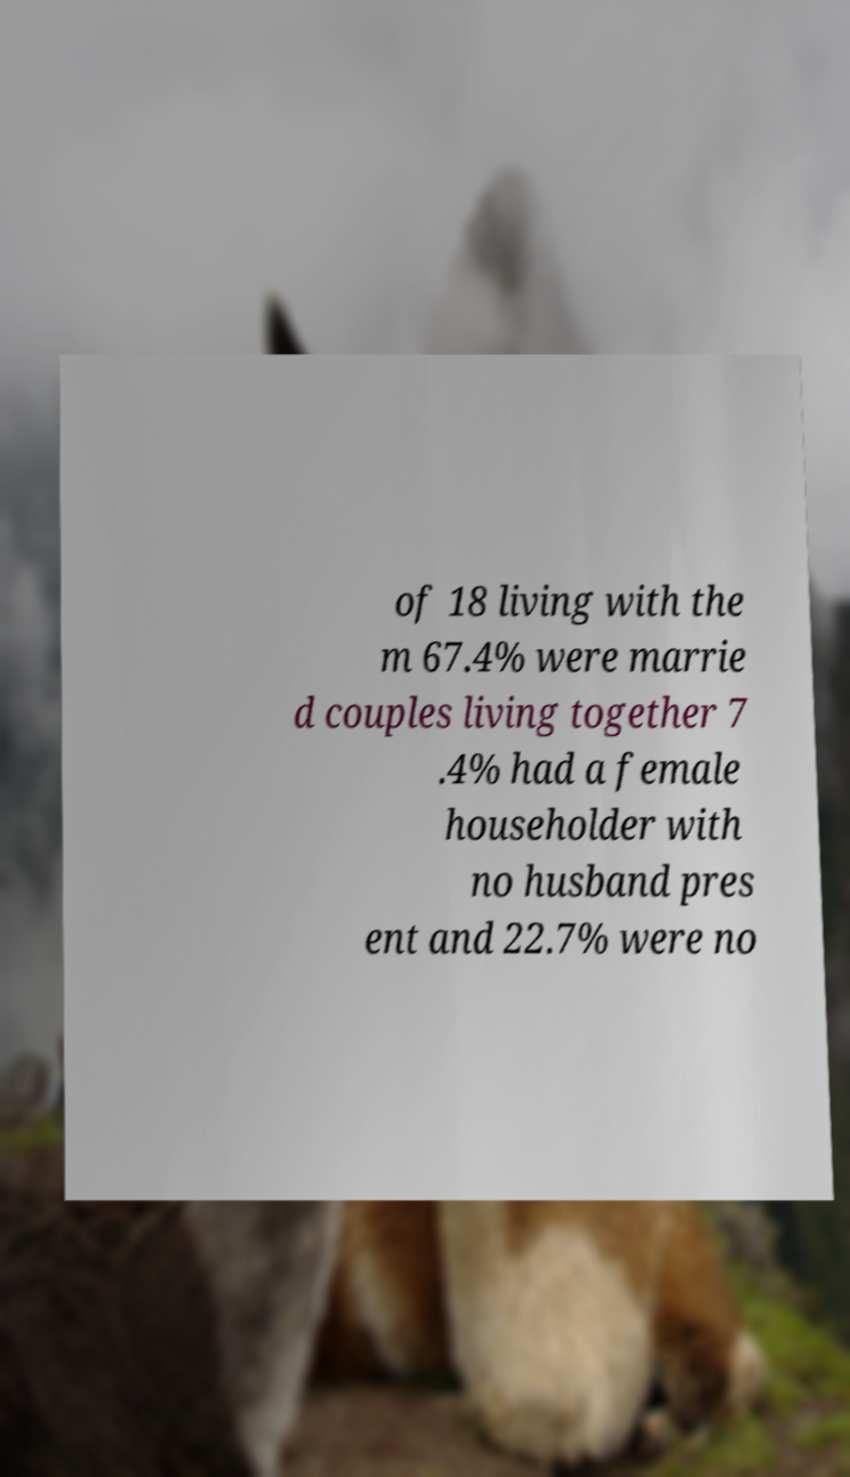Please read and relay the text visible in this image. What does it say? of 18 living with the m 67.4% were marrie d couples living together 7 .4% had a female householder with no husband pres ent and 22.7% were no 